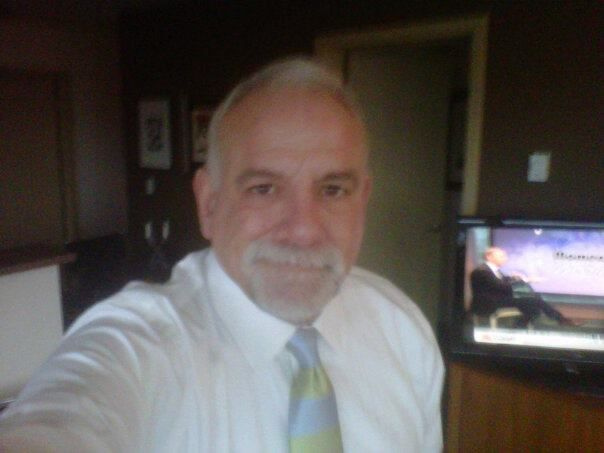<image>What color are the clothes in the drawer? It is unsure what color are the clothes in the drawer. The answer might be white. What color are the clothes in the drawer? It is unanswerable what color are the clothes in the drawer. 